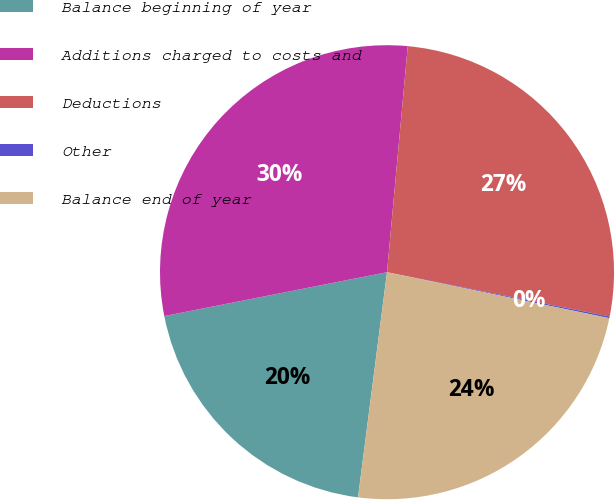Convert chart to OTSL. <chart><loc_0><loc_0><loc_500><loc_500><pie_chart><fcel>Balance beginning of year<fcel>Additions charged to costs and<fcel>Deductions<fcel>Other<fcel>Balance end of year<nl><fcel>19.87%<fcel>29.55%<fcel>26.67%<fcel>0.12%<fcel>23.79%<nl></chart> 